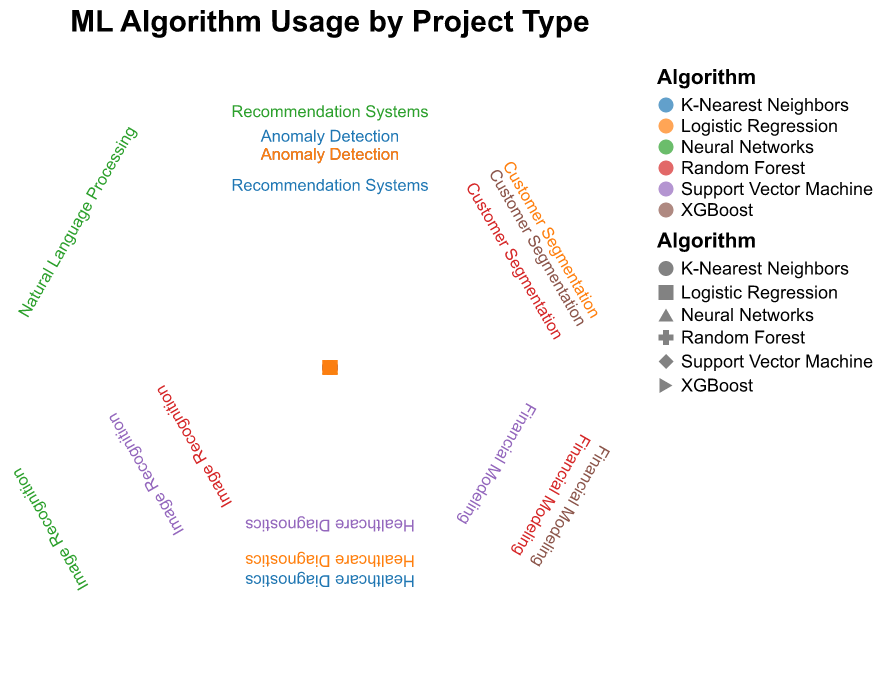What is the highest frequency for Neural Networks? The scatter plot shows frequencies using the radius of the points. For Neural Networks, the frequencies are displayed for Image Recognition, Natural Language Processing, and Recommendation Systems. The largest radius point represents Image Recognition with 25.
Answer: 25 Which algorithm is used the most for Financial Modeling? By examining the radii of the points corresponding to Financial Modeling, the largest point belongs to XGBoost with a frequency of 18.
Answer: XGBoost Compare the frequencies of Logistic Regression and K-Nearest Neighbors in Anomaly Detection. Which one is higher? Look at the points corresponding to Anomaly Detection for both Logistic Regression and K-Nearest Neighbors. Logistic Regression has 10 and K-Nearest Neighbors has 12. K-Nearest Neighbors has the higher frequency.
Answer: K-Nearest Neighbors What is the total frequency of Random Forest across all project types? Summing the frequencies of Random Forest in Financial Modeling (15), Customer Segmentation (10), and Image Recognition (5) gives a total of \(15 + 10 + 5 = 30\).
Answer: 30 Which project type has the highest combined frequency for all algorithms? Sum the frequencies of each project type across all algorithms and compare. Image Recognition: 5 (Random Forest) + 10 (Support Vector Machine) + 25 (Neural Networks) = 40, which is the highest compared to others.
Answer: Image Recognition What is the average frequency for Support Vector Machine across all project types? Add frequencies and divide by the number of project types for Support Vector Machine. (8 for Financial Modeling + 10 for Image Recognition + 5 for Healthcare Diagnostics) / 3 = \(23 / 3 \approx 7.67\).
Answer: 7.67 For Recommendation Systems, which algorithm has the lowest frequency? Examine the points for Recommendation Systems: 7 (K-Nearest Neighbors) and 15 (Neural Networks). K-Nearest Neighbors has the lowest frequency.
Answer: K-Nearest Neighbors How many project types are there in total? The scatter plot's radial axis represents different project types. Counting these labels gives a total of 7 project types.
Answer: 7 